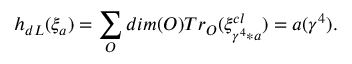Convert formula to latex. <formula><loc_0><loc_0><loc_500><loc_500>h _ { d L } ( \xi _ { a } ) = \sum _ { O } d i m ( O ) T r _ { O } ( \xi _ { \gamma ^ { 4 } * a } ^ { c l } ) = a ( \gamma ^ { 4 } ) .</formula> 